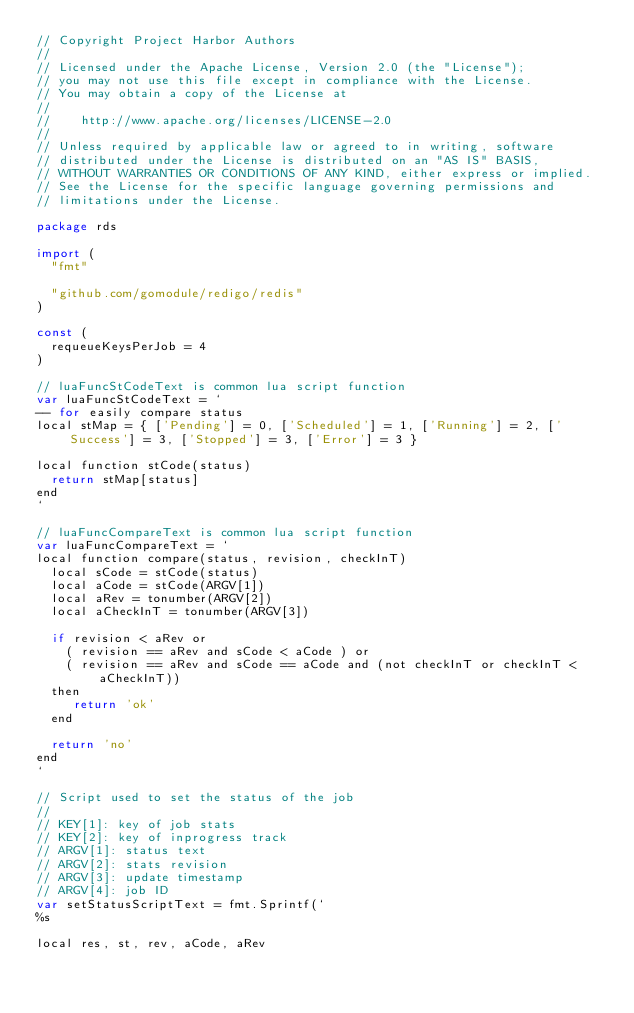<code> <loc_0><loc_0><loc_500><loc_500><_Go_>// Copyright Project Harbor Authors
//
// Licensed under the Apache License, Version 2.0 (the "License");
// you may not use this file except in compliance with the License.
// You may obtain a copy of the License at
//
//    http://www.apache.org/licenses/LICENSE-2.0
//
// Unless required by applicable law or agreed to in writing, software
// distributed under the License is distributed on an "AS IS" BASIS,
// WITHOUT WARRANTIES OR CONDITIONS OF ANY KIND, either express or implied.
// See the License for the specific language governing permissions and
// limitations under the License.

package rds

import (
	"fmt"

	"github.com/gomodule/redigo/redis"
)

const (
	requeueKeysPerJob = 4
)

// luaFuncStCodeText is common lua script function
var luaFuncStCodeText = `
-- for easily compare status
local stMap = { ['Pending'] = 0, ['Scheduled'] = 1, ['Running'] = 2, ['Success'] = 3, ['Stopped'] = 3, ['Error'] = 3 }

local function stCode(status)
  return stMap[status]
end
`

// luaFuncCompareText is common lua script function
var luaFuncCompareText = `
local function compare(status, revision, checkInT)
  local sCode = stCode(status)
  local aCode = stCode(ARGV[1])
  local aRev = tonumber(ARGV[2])
  local aCheckInT = tonumber(ARGV[3])

  if revision < aRev or 
    ( revision == aRev and sCode < aCode ) or
    ( revision == aRev and sCode == aCode and (not checkInT or checkInT < aCheckInT))
  then
     return 'ok'
  end

  return 'no'
end
`

// Script used to set the status of the job
//
// KEY[1]: key of job stats
// KEY[2]: key of inprogress track
// ARGV[1]: status text
// ARGV[2]: stats revision
// ARGV[3]: update timestamp
// ARGV[4]: job ID
var setStatusScriptText = fmt.Sprintf(`
%s

local res, st, rev, aCode, aRev
</code> 